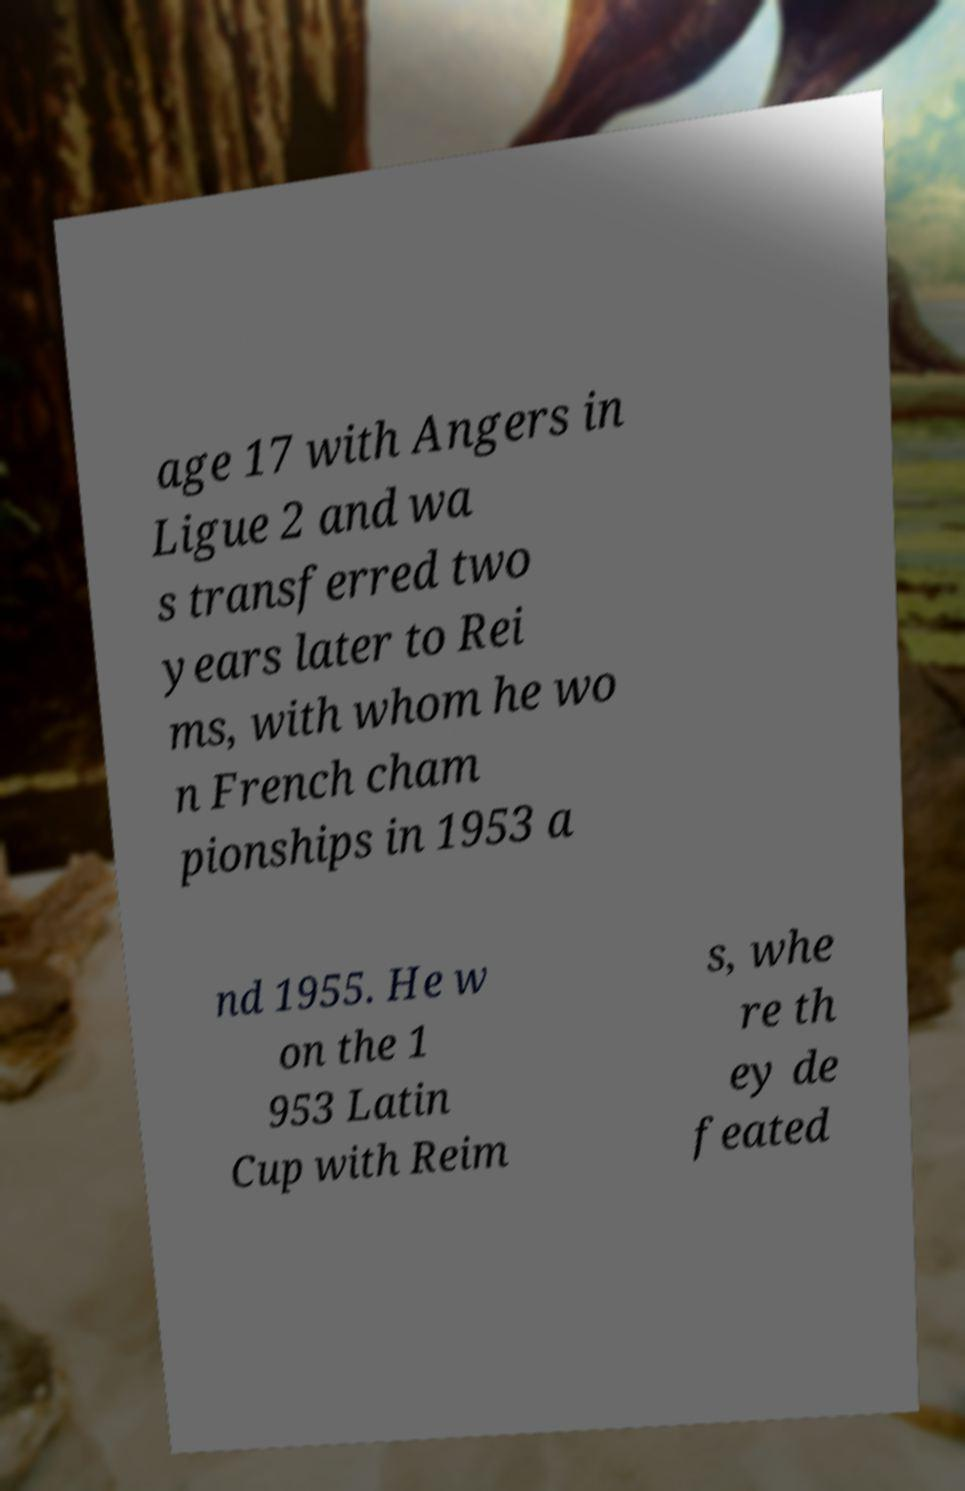Can you read and provide the text displayed in the image?This photo seems to have some interesting text. Can you extract and type it out for me? age 17 with Angers in Ligue 2 and wa s transferred two years later to Rei ms, with whom he wo n French cham pionships in 1953 a nd 1955. He w on the 1 953 Latin Cup with Reim s, whe re th ey de feated 